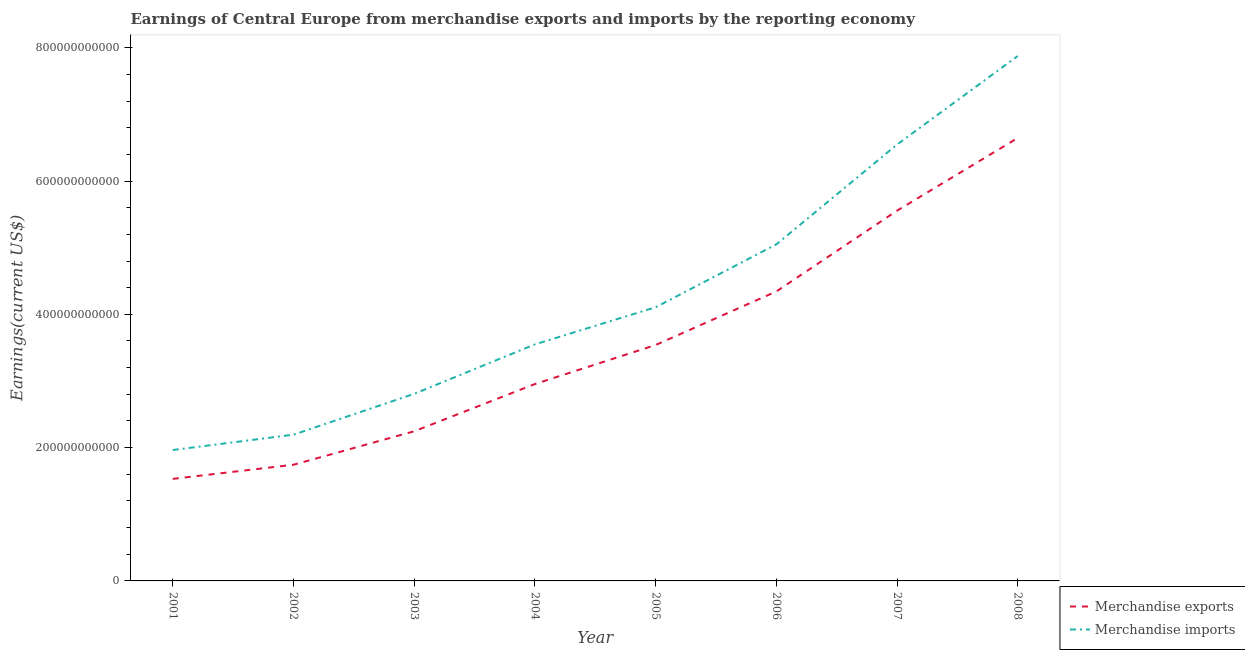Is the number of lines equal to the number of legend labels?
Your answer should be very brief. Yes. What is the earnings from merchandise imports in 2006?
Provide a succinct answer. 5.05e+11. Across all years, what is the maximum earnings from merchandise exports?
Your answer should be compact. 6.65e+11. Across all years, what is the minimum earnings from merchandise exports?
Make the answer very short. 1.53e+11. In which year was the earnings from merchandise exports maximum?
Your answer should be compact. 2008. What is the total earnings from merchandise imports in the graph?
Your answer should be compact. 3.41e+12. What is the difference between the earnings from merchandise exports in 2005 and that in 2007?
Your answer should be compact. -2.02e+11. What is the difference between the earnings from merchandise imports in 2004 and the earnings from merchandise exports in 2006?
Your answer should be very brief. -7.94e+1. What is the average earnings from merchandise imports per year?
Offer a very short reply. 4.26e+11. In the year 2001, what is the difference between the earnings from merchandise imports and earnings from merchandise exports?
Your response must be concise. 4.33e+1. What is the ratio of the earnings from merchandise imports in 2006 to that in 2008?
Give a very brief answer. 0.64. Is the difference between the earnings from merchandise exports in 2001 and 2005 greater than the difference between the earnings from merchandise imports in 2001 and 2005?
Offer a terse response. Yes. What is the difference between the highest and the second highest earnings from merchandise exports?
Provide a short and direct response. 1.09e+11. What is the difference between the highest and the lowest earnings from merchandise imports?
Provide a short and direct response. 5.91e+11. In how many years, is the earnings from merchandise exports greater than the average earnings from merchandise exports taken over all years?
Offer a terse response. 3. Is the earnings from merchandise imports strictly greater than the earnings from merchandise exports over the years?
Your response must be concise. Yes. How many lines are there?
Your answer should be compact. 2. How many years are there in the graph?
Your answer should be very brief. 8. What is the difference between two consecutive major ticks on the Y-axis?
Your response must be concise. 2.00e+11. Does the graph contain any zero values?
Keep it short and to the point. No. Does the graph contain grids?
Your answer should be compact. No. How many legend labels are there?
Provide a succinct answer. 2. What is the title of the graph?
Provide a succinct answer. Earnings of Central Europe from merchandise exports and imports by the reporting economy. What is the label or title of the X-axis?
Offer a terse response. Year. What is the label or title of the Y-axis?
Provide a short and direct response. Earnings(current US$). What is the Earnings(current US$) in Merchandise exports in 2001?
Provide a succinct answer. 1.53e+11. What is the Earnings(current US$) of Merchandise imports in 2001?
Offer a very short reply. 1.96e+11. What is the Earnings(current US$) in Merchandise exports in 2002?
Keep it short and to the point. 1.74e+11. What is the Earnings(current US$) in Merchandise imports in 2002?
Your response must be concise. 2.19e+11. What is the Earnings(current US$) of Merchandise exports in 2003?
Ensure brevity in your answer.  2.25e+11. What is the Earnings(current US$) of Merchandise imports in 2003?
Your answer should be compact. 2.81e+11. What is the Earnings(current US$) in Merchandise exports in 2004?
Your response must be concise. 2.95e+11. What is the Earnings(current US$) in Merchandise imports in 2004?
Give a very brief answer. 3.55e+11. What is the Earnings(current US$) in Merchandise exports in 2005?
Give a very brief answer. 3.54e+11. What is the Earnings(current US$) of Merchandise imports in 2005?
Give a very brief answer. 4.11e+11. What is the Earnings(current US$) in Merchandise exports in 2006?
Offer a very short reply. 4.34e+11. What is the Earnings(current US$) in Merchandise imports in 2006?
Provide a succinct answer. 5.05e+11. What is the Earnings(current US$) in Merchandise exports in 2007?
Your answer should be very brief. 5.56e+11. What is the Earnings(current US$) in Merchandise imports in 2007?
Your answer should be very brief. 6.55e+11. What is the Earnings(current US$) of Merchandise exports in 2008?
Ensure brevity in your answer.  6.65e+11. What is the Earnings(current US$) in Merchandise imports in 2008?
Make the answer very short. 7.88e+11. Across all years, what is the maximum Earnings(current US$) in Merchandise exports?
Provide a short and direct response. 6.65e+11. Across all years, what is the maximum Earnings(current US$) in Merchandise imports?
Your answer should be compact. 7.88e+11. Across all years, what is the minimum Earnings(current US$) in Merchandise exports?
Give a very brief answer. 1.53e+11. Across all years, what is the minimum Earnings(current US$) of Merchandise imports?
Keep it short and to the point. 1.96e+11. What is the total Earnings(current US$) in Merchandise exports in the graph?
Your answer should be very brief. 2.86e+12. What is the total Earnings(current US$) in Merchandise imports in the graph?
Keep it short and to the point. 3.41e+12. What is the difference between the Earnings(current US$) of Merchandise exports in 2001 and that in 2002?
Your answer should be very brief. -2.12e+1. What is the difference between the Earnings(current US$) of Merchandise imports in 2001 and that in 2002?
Provide a succinct answer. -2.30e+1. What is the difference between the Earnings(current US$) of Merchandise exports in 2001 and that in 2003?
Offer a terse response. -7.14e+1. What is the difference between the Earnings(current US$) of Merchandise imports in 2001 and that in 2003?
Offer a terse response. -8.43e+1. What is the difference between the Earnings(current US$) of Merchandise exports in 2001 and that in 2004?
Give a very brief answer. -1.42e+11. What is the difference between the Earnings(current US$) of Merchandise imports in 2001 and that in 2004?
Provide a succinct answer. -1.58e+11. What is the difference between the Earnings(current US$) in Merchandise exports in 2001 and that in 2005?
Keep it short and to the point. -2.01e+11. What is the difference between the Earnings(current US$) of Merchandise imports in 2001 and that in 2005?
Your answer should be compact. -2.14e+11. What is the difference between the Earnings(current US$) of Merchandise exports in 2001 and that in 2006?
Give a very brief answer. -2.81e+11. What is the difference between the Earnings(current US$) in Merchandise imports in 2001 and that in 2006?
Keep it short and to the point. -3.09e+11. What is the difference between the Earnings(current US$) of Merchandise exports in 2001 and that in 2007?
Offer a terse response. -4.02e+11. What is the difference between the Earnings(current US$) in Merchandise imports in 2001 and that in 2007?
Your response must be concise. -4.58e+11. What is the difference between the Earnings(current US$) in Merchandise exports in 2001 and that in 2008?
Provide a short and direct response. -5.12e+11. What is the difference between the Earnings(current US$) in Merchandise imports in 2001 and that in 2008?
Provide a succinct answer. -5.91e+11. What is the difference between the Earnings(current US$) of Merchandise exports in 2002 and that in 2003?
Offer a very short reply. -5.02e+1. What is the difference between the Earnings(current US$) of Merchandise imports in 2002 and that in 2003?
Provide a short and direct response. -6.13e+1. What is the difference between the Earnings(current US$) of Merchandise exports in 2002 and that in 2004?
Offer a terse response. -1.21e+11. What is the difference between the Earnings(current US$) in Merchandise imports in 2002 and that in 2004?
Offer a very short reply. -1.35e+11. What is the difference between the Earnings(current US$) in Merchandise exports in 2002 and that in 2005?
Provide a succinct answer. -1.80e+11. What is the difference between the Earnings(current US$) in Merchandise imports in 2002 and that in 2005?
Make the answer very short. -1.91e+11. What is the difference between the Earnings(current US$) in Merchandise exports in 2002 and that in 2006?
Keep it short and to the point. -2.60e+11. What is the difference between the Earnings(current US$) in Merchandise imports in 2002 and that in 2006?
Provide a succinct answer. -2.86e+11. What is the difference between the Earnings(current US$) in Merchandise exports in 2002 and that in 2007?
Ensure brevity in your answer.  -3.81e+11. What is the difference between the Earnings(current US$) of Merchandise imports in 2002 and that in 2007?
Give a very brief answer. -4.35e+11. What is the difference between the Earnings(current US$) in Merchandise exports in 2002 and that in 2008?
Offer a terse response. -4.90e+11. What is the difference between the Earnings(current US$) of Merchandise imports in 2002 and that in 2008?
Offer a very short reply. -5.68e+11. What is the difference between the Earnings(current US$) of Merchandise exports in 2003 and that in 2004?
Your response must be concise. -7.09e+1. What is the difference between the Earnings(current US$) of Merchandise imports in 2003 and that in 2004?
Your answer should be very brief. -7.42e+1. What is the difference between the Earnings(current US$) in Merchandise exports in 2003 and that in 2005?
Offer a terse response. -1.29e+11. What is the difference between the Earnings(current US$) of Merchandise imports in 2003 and that in 2005?
Your answer should be very brief. -1.30e+11. What is the difference between the Earnings(current US$) in Merchandise exports in 2003 and that in 2006?
Make the answer very short. -2.10e+11. What is the difference between the Earnings(current US$) in Merchandise imports in 2003 and that in 2006?
Make the answer very short. -2.24e+11. What is the difference between the Earnings(current US$) of Merchandise exports in 2003 and that in 2007?
Ensure brevity in your answer.  -3.31e+11. What is the difference between the Earnings(current US$) in Merchandise imports in 2003 and that in 2007?
Your answer should be very brief. -3.74e+11. What is the difference between the Earnings(current US$) in Merchandise exports in 2003 and that in 2008?
Provide a succinct answer. -4.40e+11. What is the difference between the Earnings(current US$) of Merchandise imports in 2003 and that in 2008?
Offer a terse response. -5.07e+11. What is the difference between the Earnings(current US$) in Merchandise exports in 2004 and that in 2005?
Ensure brevity in your answer.  -5.85e+1. What is the difference between the Earnings(current US$) in Merchandise imports in 2004 and that in 2005?
Offer a very short reply. -5.57e+1. What is the difference between the Earnings(current US$) of Merchandise exports in 2004 and that in 2006?
Your answer should be very brief. -1.39e+11. What is the difference between the Earnings(current US$) of Merchandise imports in 2004 and that in 2006?
Provide a succinct answer. -1.50e+11. What is the difference between the Earnings(current US$) in Merchandise exports in 2004 and that in 2007?
Ensure brevity in your answer.  -2.60e+11. What is the difference between the Earnings(current US$) in Merchandise imports in 2004 and that in 2007?
Offer a terse response. -3.00e+11. What is the difference between the Earnings(current US$) in Merchandise exports in 2004 and that in 2008?
Ensure brevity in your answer.  -3.69e+11. What is the difference between the Earnings(current US$) in Merchandise imports in 2004 and that in 2008?
Provide a succinct answer. -4.33e+11. What is the difference between the Earnings(current US$) in Merchandise exports in 2005 and that in 2006?
Offer a very short reply. -8.04e+1. What is the difference between the Earnings(current US$) of Merchandise imports in 2005 and that in 2006?
Your response must be concise. -9.44e+1. What is the difference between the Earnings(current US$) in Merchandise exports in 2005 and that in 2007?
Provide a succinct answer. -2.02e+11. What is the difference between the Earnings(current US$) in Merchandise imports in 2005 and that in 2007?
Give a very brief answer. -2.44e+11. What is the difference between the Earnings(current US$) of Merchandise exports in 2005 and that in 2008?
Keep it short and to the point. -3.11e+11. What is the difference between the Earnings(current US$) of Merchandise imports in 2005 and that in 2008?
Your answer should be compact. -3.77e+11. What is the difference between the Earnings(current US$) in Merchandise exports in 2006 and that in 2007?
Keep it short and to the point. -1.21e+11. What is the difference between the Earnings(current US$) of Merchandise imports in 2006 and that in 2007?
Offer a very short reply. -1.50e+11. What is the difference between the Earnings(current US$) in Merchandise exports in 2006 and that in 2008?
Your answer should be very brief. -2.30e+11. What is the difference between the Earnings(current US$) in Merchandise imports in 2006 and that in 2008?
Make the answer very short. -2.83e+11. What is the difference between the Earnings(current US$) in Merchandise exports in 2007 and that in 2008?
Make the answer very short. -1.09e+11. What is the difference between the Earnings(current US$) in Merchandise imports in 2007 and that in 2008?
Give a very brief answer. -1.33e+11. What is the difference between the Earnings(current US$) in Merchandise exports in 2001 and the Earnings(current US$) in Merchandise imports in 2002?
Provide a succinct answer. -6.63e+1. What is the difference between the Earnings(current US$) of Merchandise exports in 2001 and the Earnings(current US$) of Merchandise imports in 2003?
Make the answer very short. -1.28e+11. What is the difference between the Earnings(current US$) of Merchandise exports in 2001 and the Earnings(current US$) of Merchandise imports in 2004?
Make the answer very short. -2.02e+11. What is the difference between the Earnings(current US$) of Merchandise exports in 2001 and the Earnings(current US$) of Merchandise imports in 2005?
Your response must be concise. -2.58e+11. What is the difference between the Earnings(current US$) in Merchandise exports in 2001 and the Earnings(current US$) in Merchandise imports in 2006?
Keep it short and to the point. -3.52e+11. What is the difference between the Earnings(current US$) in Merchandise exports in 2001 and the Earnings(current US$) in Merchandise imports in 2007?
Provide a succinct answer. -5.02e+11. What is the difference between the Earnings(current US$) of Merchandise exports in 2001 and the Earnings(current US$) of Merchandise imports in 2008?
Ensure brevity in your answer.  -6.34e+11. What is the difference between the Earnings(current US$) of Merchandise exports in 2002 and the Earnings(current US$) of Merchandise imports in 2003?
Keep it short and to the point. -1.06e+11. What is the difference between the Earnings(current US$) of Merchandise exports in 2002 and the Earnings(current US$) of Merchandise imports in 2004?
Provide a succinct answer. -1.81e+11. What is the difference between the Earnings(current US$) in Merchandise exports in 2002 and the Earnings(current US$) in Merchandise imports in 2005?
Your response must be concise. -2.36e+11. What is the difference between the Earnings(current US$) in Merchandise exports in 2002 and the Earnings(current US$) in Merchandise imports in 2006?
Offer a terse response. -3.31e+11. What is the difference between the Earnings(current US$) in Merchandise exports in 2002 and the Earnings(current US$) in Merchandise imports in 2007?
Your answer should be very brief. -4.80e+11. What is the difference between the Earnings(current US$) in Merchandise exports in 2002 and the Earnings(current US$) in Merchandise imports in 2008?
Give a very brief answer. -6.13e+11. What is the difference between the Earnings(current US$) of Merchandise exports in 2003 and the Earnings(current US$) of Merchandise imports in 2004?
Offer a terse response. -1.30e+11. What is the difference between the Earnings(current US$) of Merchandise exports in 2003 and the Earnings(current US$) of Merchandise imports in 2005?
Make the answer very short. -1.86e+11. What is the difference between the Earnings(current US$) in Merchandise exports in 2003 and the Earnings(current US$) in Merchandise imports in 2006?
Provide a short and direct response. -2.80e+11. What is the difference between the Earnings(current US$) in Merchandise exports in 2003 and the Earnings(current US$) in Merchandise imports in 2007?
Keep it short and to the point. -4.30e+11. What is the difference between the Earnings(current US$) of Merchandise exports in 2003 and the Earnings(current US$) of Merchandise imports in 2008?
Provide a short and direct response. -5.63e+11. What is the difference between the Earnings(current US$) of Merchandise exports in 2004 and the Earnings(current US$) of Merchandise imports in 2005?
Give a very brief answer. -1.15e+11. What is the difference between the Earnings(current US$) in Merchandise exports in 2004 and the Earnings(current US$) in Merchandise imports in 2006?
Offer a terse response. -2.10e+11. What is the difference between the Earnings(current US$) in Merchandise exports in 2004 and the Earnings(current US$) in Merchandise imports in 2007?
Provide a short and direct response. -3.59e+11. What is the difference between the Earnings(current US$) of Merchandise exports in 2004 and the Earnings(current US$) of Merchandise imports in 2008?
Your response must be concise. -4.92e+11. What is the difference between the Earnings(current US$) in Merchandise exports in 2005 and the Earnings(current US$) in Merchandise imports in 2006?
Your answer should be compact. -1.51e+11. What is the difference between the Earnings(current US$) in Merchandise exports in 2005 and the Earnings(current US$) in Merchandise imports in 2007?
Keep it short and to the point. -3.01e+11. What is the difference between the Earnings(current US$) in Merchandise exports in 2005 and the Earnings(current US$) in Merchandise imports in 2008?
Give a very brief answer. -4.34e+11. What is the difference between the Earnings(current US$) of Merchandise exports in 2006 and the Earnings(current US$) of Merchandise imports in 2007?
Your response must be concise. -2.20e+11. What is the difference between the Earnings(current US$) of Merchandise exports in 2006 and the Earnings(current US$) of Merchandise imports in 2008?
Offer a terse response. -3.53e+11. What is the difference between the Earnings(current US$) in Merchandise exports in 2007 and the Earnings(current US$) in Merchandise imports in 2008?
Your answer should be very brief. -2.32e+11. What is the average Earnings(current US$) of Merchandise exports per year?
Ensure brevity in your answer.  3.57e+11. What is the average Earnings(current US$) in Merchandise imports per year?
Ensure brevity in your answer.  4.26e+11. In the year 2001, what is the difference between the Earnings(current US$) in Merchandise exports and Earnings(current US$) in Merchandise imports?
Provide a short and direct response. -4.33e+1. In the year 2002, what is the difference between the Earnings(current US$) in Merchandise exports and Earnings(current US$) in Merchandise imports?
Ensure brevity in your answer.  -4.51e+1. In the year 2003, what is the difference between the Earnings(current US$) of Merchandise exports and Earnings(current US$) of Merchandise imports?
Your answer should be compact. -5.62e+1. In the year 2004, what is the difference between the Earnings(current US$) of Merchandise exports and Earnings(current US$) of Merchandise imports?
Make the answer very short. -5.95e+1. In the year 2005, what is the difference between the Earnings(current US$) in Merchandise exports and Earnings(current US$) in Merchandise imports?
Offer a very short reply. -5.66e+1. In the year 2006, what is the difference between the Earnings(current US$) in Merchandise exports and Earnings(current US$) in Merchandise imports?
Make the answer very short. -7.06e+1. In the year 2007, what is the difference between the Earnings(current US$) of Merchandise exports and Earnings(current US$) of Merchandise imports?
Offer a terse response. -9.92e+1. In the year 2008, what is the difference between the Earnings(current US$) of Merchandise exports and Earnings(current US$) of Merchandise imports?
Offer a terse response. -1.23e+11. What is the ratio of the Earnings(current US$) of Merchandise exports in 2001 to that in 2002?
Provide a short and direct response. 0.88. What is the ratio of the Earnings(current US$) of Merchandise imports in 2001 to that in 2002?
Make the answer very short. 0.9. What is the ratio of the Earnings(current US$) of Merchandise exports in 2001 to that in 2003?
Offer a very short reply. 0.68. What is the ratio of the Earnings(current US$) in Merchandise imports in 2001 to that in 2003?
Your answer should be very brief. 0.7. What is the ratio of the Earnings(current US$) in Merchandise exports in 2001 to that in 2004?
Provide a succinct answer. 0.52. What is the ratio of the Earnings(current US$) of Merchandise imports in 2001 to that in 2004?
Keep it short and to the point. 0.55. What is the ratio of the Earnings(current US$) in Merchandise exports in 2001 to that in 2005?
Keep it short and to the point. 0.43. What is the ratio of the Earnings(current US$) of Merchandise imports in 2001 to that in 2005?
Offer a terse response. 0.48. What is the ratio of the Earnings(current US$) in Merchandise exports in 2001 to that in 2006?
Provide a short and direct response. 0.35. What is the ratio of the Earnings(current US$) in Merchandise imports in 2001 to that in 2006?
Offer a very short reply. 0.39. What is the ratio of the Earnings(current US$) in Merchandise exports in 2001 to that in 2007?
Make the answer very short. 0.28. What is the ratio of the Earnings(current US$) in Merchandise exports in 2001 to that in 2008?
Provide a succinct answer. 0.23. What is the ratio of the Earnings(current US$) of Merchandise imports in 2001 to that in 2008?
Your response must be concise. 0.25. What is the ratio of the Earnings(current US$) in Merchandise exports in 2002 to that in 2003?
Keep it short and to the point. 0.78. What is the ratio of the Earnings(current US$) of Merchandise imports in 2002 to that in 2003?
Give a very brief answer. 0.78. What is the ratio of the Earnings(current US$) of Merchandise exports in 2002 to that in 2004?
Keep it short and to the point. 0.59. What is the ratio of the Earnings(current US$) of Merchandise imports in 2002 to that in 2004?
Offer a very short reply. 0.62. What is the ratio of the Earnings(current US$) in Merchandise exports in 2002 to that in 2005?
Provide a succinct answer. 0.49. What is the ratio of the Earnings(current US$) of Merchandise imports in 2002 to that in 2005?
Provide a short and direct response. 0.53. What is the ratio of the Earnings(current US$) of Merchandise exports in 2002 to that in 2006?
Provide a short and direct response. 0.4. What is the ratio of the Earnings(current US$) in Merchandise imports in 2002 to that in 2006?
Your response must be concise. 0.43. What is the ratio of the Earnings(current US$) in Merchandise exports in 2002 to that in 2007?
Your response must be concise. 0.31. What is the ratio of the Earnings(current US$) in Merchandise imports in 2002 to that in 2007?
Give a very brief answer. 0.34. What is the ratio of the Earnings(current US$) in Merchandise exports in 2002 to that in 2008?
Your answer should be very brief. 0.26. What is the ratio of the Earnings(current US$) in Merchandise imports in 2002 to that in 2008?
Ensure brevity in your answer.  0.28. What is the ratio of the Earnings(current US$) of Merchandise exports in 2003 to that in 2004?
Ensure brevity in your answer.  0.76. What is the ratio of the Earnings(current US$) in Merchandise imports in 2003 to that in 2004?
Your response must be concise. 0.79. What is the ratio of the Earnings(current US$) of Merchandise exports in 2003 to that in 2005?
Give a very brief answer. 0.63. What is the ratio of the Earnings(current US$) of Merchandise imports in 2003 to that in 2005?
Your answer should be very brief. 0.68. What is the ratio of the Earnings(current US$) of Merchandise exports in 2003 to that in 2006?
Your response must be concise. 0.52. What is the ratio of the Earnings(current US$) in Merchandise imports in 2003 to that in 2006?
Your answer should be compact. 0.56. What is the ratio of the Earnings(current US$) in Merchandise exports in 2003 to that in 2007?
Your answer should be very brief. 0.4. What is the ratio of the Earnings(current US$) in Merchandise imports in 2003 to that in 2007?
Ensure brevity in your answer.  0.43. What is the ratio of the Earnings(current US$) of Merchandise exports in 2003 to that in 2008?
Keep it short and to the point. 0.34. What is the ratio of the Earnings(current US$) of Merchandise imports in 2003 to that in 2008?
Keep it short and to the point. 0.36. What is the ratio of the Earnings(current US$) in Merchandise exports in 2004 to that in 2005?
Provide a succinct answer. 0.83. What is the ratio of the Earnings(current US$) of Merchandise imports in 2004 to that in 2005?
Offer a very short reply. 0.86. What is the ratio of the Earnings(current US$) in Merchandise exports in 2004 to that in 2006?
Ensure brevity in your answer.  0.68. What is the ratio of the Earnings(current US$) of Merchandise imports in 2004 to that in 2006?
Your answer should be very brief. 0.7. What is the ratio of the Earnings(current US$) of Merchandise exports in 2004 to that in 2007?
Make the answer very short. 0.53. What is the ratio of the Earnings(current US$) in Merchandise imports in 2004 to that in 2007?
Keep it short and to the point. 0.54. What is the ratio of the Earnings(current US$) of Merchandise exports in 2004 to that in 2008?
Provide a short and direct response. 0.44. What is the ratio of the Earnings(current US$) in Merchandise imports in 2004 to that in 2008?
Give a very brief answer. 0.45. What is the ratio of the Earnings(current US$) in Merchandise exports in 2005 to that in 2006?
Offer a very short reply. 0.81. What is the ratio of the Earnings(current US$) of Merchandise imports in 2005 to that in 2006?
Offer a terse response. 0.81. What is the ratio of the Earnings(current US$) in Merchandise exports in 2005 to that in 2007?
Give a very brief answer. 0.64. What is the ratio of the Earnings(current US$) of Merchandise imports in 2005 to that in 2007?
Offer a terse response. 0.63. What is the ratio of the Earnings(current US$) of Merchandise exports in 2005 to that in 2008?
Make the answer very short. 0.53. What is the ratio of the Earnings(current US$) of Merchandise imports in 2005 to that in 2008?
Make the answer very short. 0.52. What is the ratio of the Earnings(current US$) of Merchandise exports in 2006 to that in 2007?
Make the answer very short. 0.78. What is the ratio of the Earnings(current US$) of Merchandise imports in 2006 to that in 2007?
Keep it short and to the point. 0.77. What is the ratio of the Earnings(current US$) in Merchandise exports in 2006 to that in 2008?
Keep it short and to the point. 0.65. What is the ratio of the Earnings(current US$) of Merchandise imports in 2006 to that in 2008?
Your answer should be compact. 0.64. What is the ratio of the Earnings(current US$) in Merchandise exports in 2007 to that in 2008?
Give a very brief answer. 0.84. What is the ratio of the Earnings(current US$) in Merchandise imports in 2007 to that in 2008?
Provide a succinct answer. 0.83. What is the difference between the highest and the second highest Earnings(current US$) of Merchandise exports?
Ensure brevity in your answer.  1.09e+11. What is the difference between the highest and the second highest Earnings(current US$) of Merchandise imports?
Ensure brevity in your answer.  1.33e+11. What is the difference between the highest and the lowest Earnings(current US$) of Merchandise exports?
Your answer should be very brief. 5.12e+11. What is the difference between the highest and the lowest Earnings(current US$) in Merchandise imports?
Your response must be concise. 5.91e+11. 